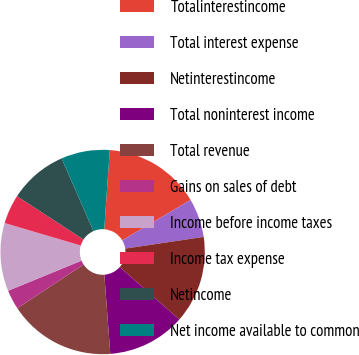Convert chart. <chart><loc_0><loc_0><loc_500><loc_500><pie_chart><fcel>Totalinterestincome<fcel>Total interest expense<fcel>Netinterestincome<fcel>Total noninterest income<fcel>Total revenue<fcel>Gains on sales of debt<fcel>Income before income taxes<fcel>Income tax expense<fcel>Netincome<fcel>Net income available to common<nl><fcel>15.38%<fcel>6.15%<fcel>13.85%<fcel>12.31%<fcel>16.92%<fcel>3.08%<fcel>10.77%<fcel>4.62%<fcel>9.23%<fcel>7.69%<nl></chart> 